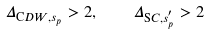<formula> <loc_0><loc_0><loc_500><loc_500>\Delta _ { { \mathrm C D W } , s _ { p } } > 2 , \quad \Delta _ { { \mathrm S C } , s ^ { ^ { \prime } } _ { p } } > 2</formula> 